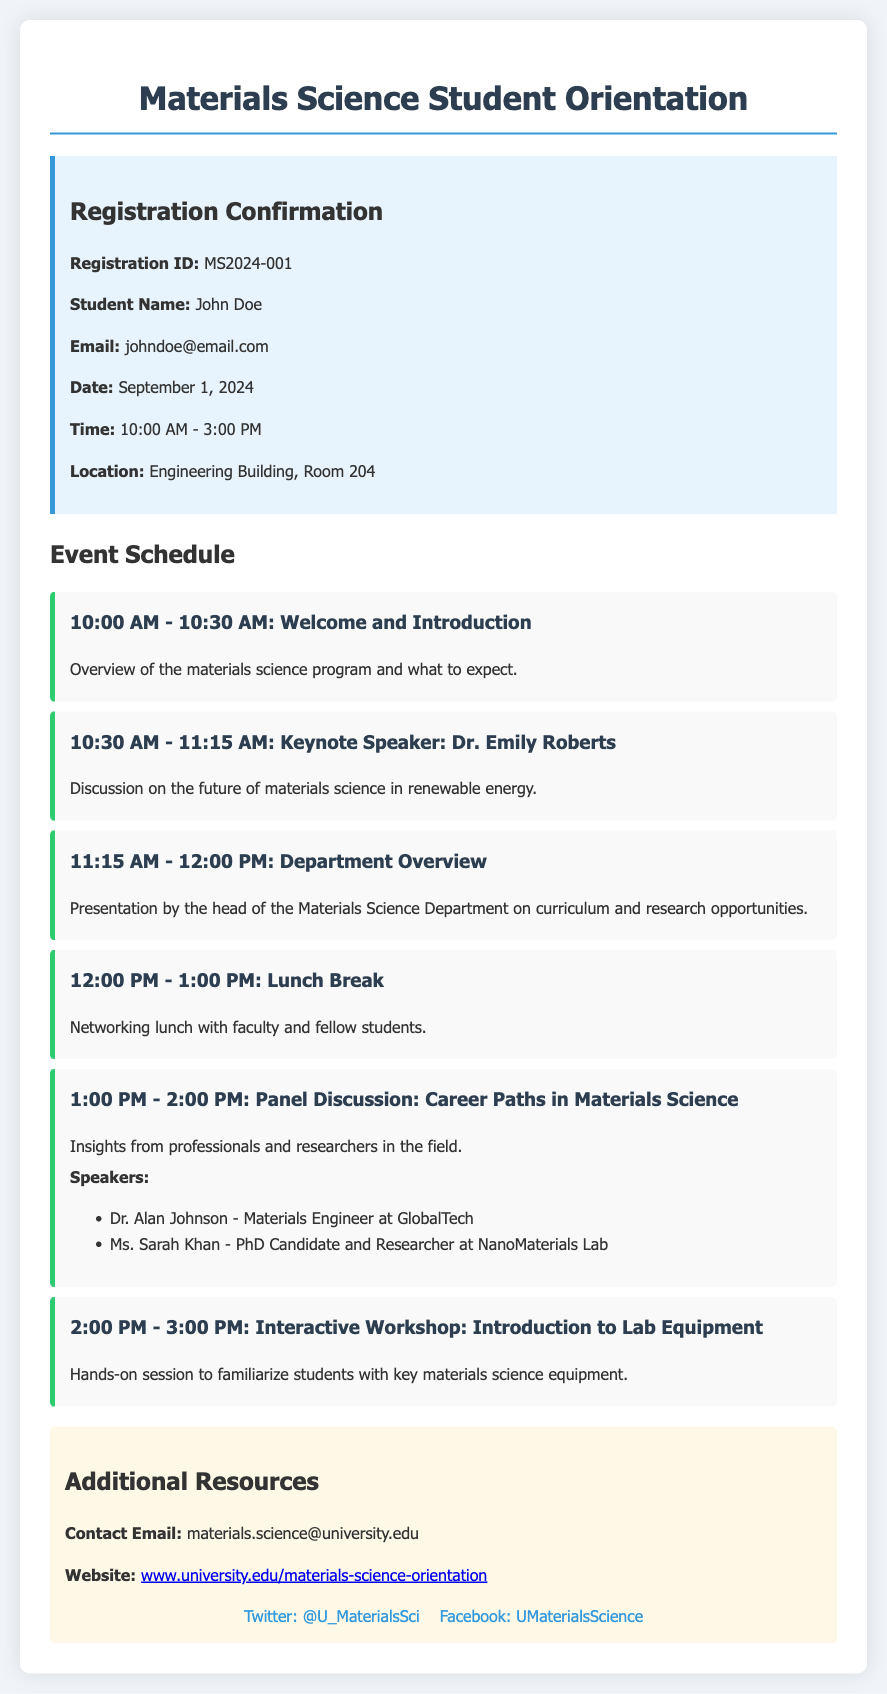What is the registration ID? The registration ID is found in the confirmation details section of the document.
Answer: MS2024-001 What is the name of the keynote speaker? The name of the keynote speaker is mentioned in the schedule section.
Answer: Dr. Emily Roberts What time does the lunch break start? The lunch break time is indicated in the event schedule.
Answer: 12:00 PM How many speakers are participating in the panel discussion? The number of speakers is listed in the panel discussion schedule item.
Answer: 2 What is the location of the orientation event? The location is specified in the confirmation details.
Answer: Engineering Building, Room 204 What is the main topic of the panel discussion? The main topic is given in the schedule for the panel discussion.
Answer: Career Paths in Materials Science What is the duration of the interactive workshop? The duration of the workshop is stated in the schedule section.
Answer: 1 hour What is provided during the lunch break? The lunch break section describes what is available to the attendees.
Answer: Networking lunch Where can I find additional resources related to the orientation? Additional resources are described in the additional info section of the document.
Answer: Materials science website 